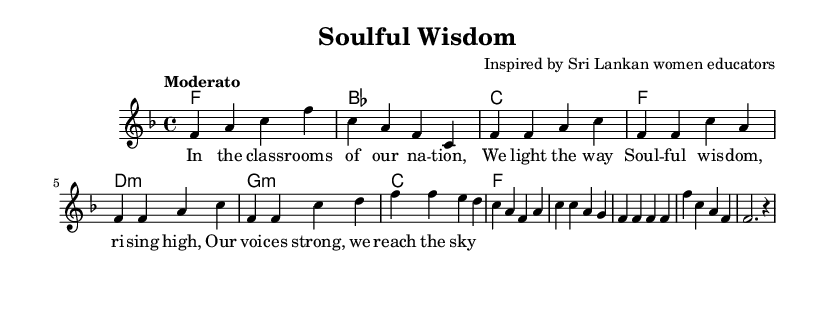What is the key signature of this music? The key signature is F major, indicated by one flat (B flat).
Answer: F major What is the time signature of this piece? The time signature is 4/4, which means there are four beats in a measure.
Answer: 4/4 What tempo marking is indicated in this score? The tempo marking is "Moderato," suggesting a moderate pace.
Answer: Moderato How many measures are in the verse section? The verse consists of four measures, as evident from the layout of the melody.
Answer: Four measures What type of chords are primarily used in this piece? The chords used are major and minor chords, which is typical for soul music to evoke emotional responses.
Answer: Major and minor chords What phrase is repeated in the lyrics? The phrase "we reach the sky" suggests perseverance and aspiration, which resonates with the soul genre's themes.
Answer: "we reach the sky." What is the name of the composition? The title of the composition is "Soulful Wisdom," reflecting the empowerment theme in education.
Answer: Soulful Wisdom 